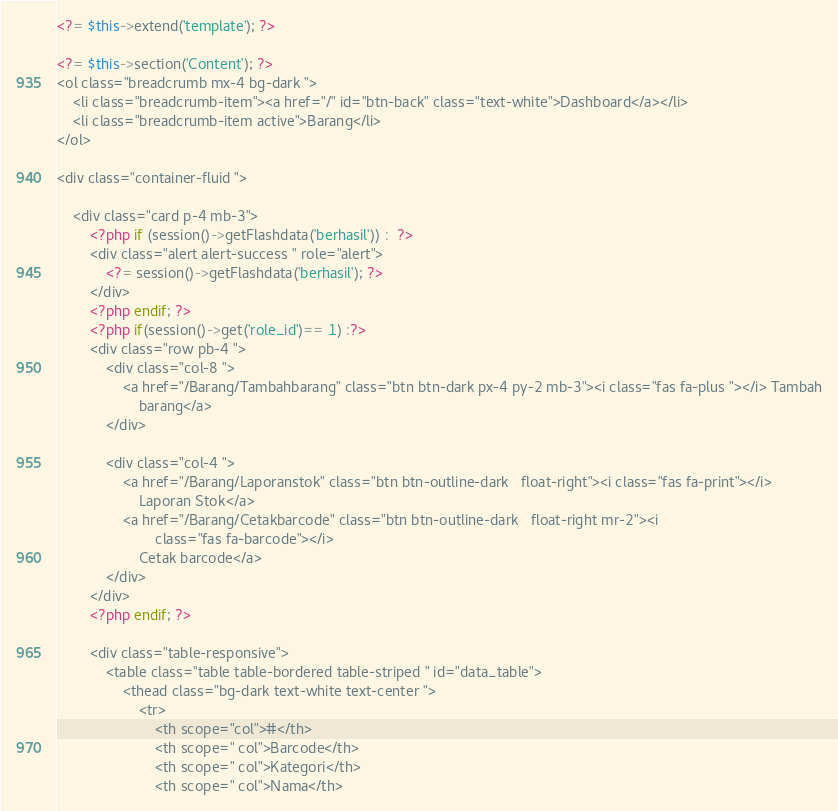Convert code to text. <code><loc_0><loc_0><loc_500><loc_500><_PHP_><?= $this->extend('template'); ?>

<?= $this->section('Content'); ?>
<ol class="breadcrumb mx-4 bg-dark ">
    <li class="breadcrumb-item"><a href="/" id="btn-back" class="text-white">Dashboard</a></li>
    <li class="breadcrumb-item active">Barang</li>
</ol>

<div class="container-fluid ">

    <div class="card p-4 mb-3">
        <?php if (session()->getFlashdata('berhasil')) :  ?>
        <div class="alert alert-success " role="alert">
            <?= session()->getFlashdata('berhasil'); ?>
        </div>
        <?php endif; ?>
        <?php if(session()->get('role_id')== 1) :?>
        <div class="row pb-4 ">
            <div class="col-8 ">
                <a href="/Barang/Tambahbarang" class="btn btn-dark px-4 py-2 mb-3"><i class="fas fa-plus "></i> Tambah
                    barang</a>
            </div>

            <div class="col-4 ">
                <a href="/Barang/Laporanstok" class="btn btn-outline-dark   float-right"><i class="fas fa-print"></i>
                    Laporan Stok</a>
                <a href="/Barang/Cetakbarcode" class="btn btn-outline-dark   float-right mr-2"><i
                        class="fas fa-barcode"></i>
                    Cetak barcode</a>
            </div>
        </div>
        <?php endif; ?>

        <div class="table-responsive">
            <table class="table table-bordered table-striped " id="data_table">
                <thead class="bg-dark text-white text-center ">
                    <tr>
                        <th scope="col">#</th>
                        <th scope=" col">Barcode</th>
                        <th scope=" col">Kategori</th>
                        <th scope=" col">Nama</th></code> 